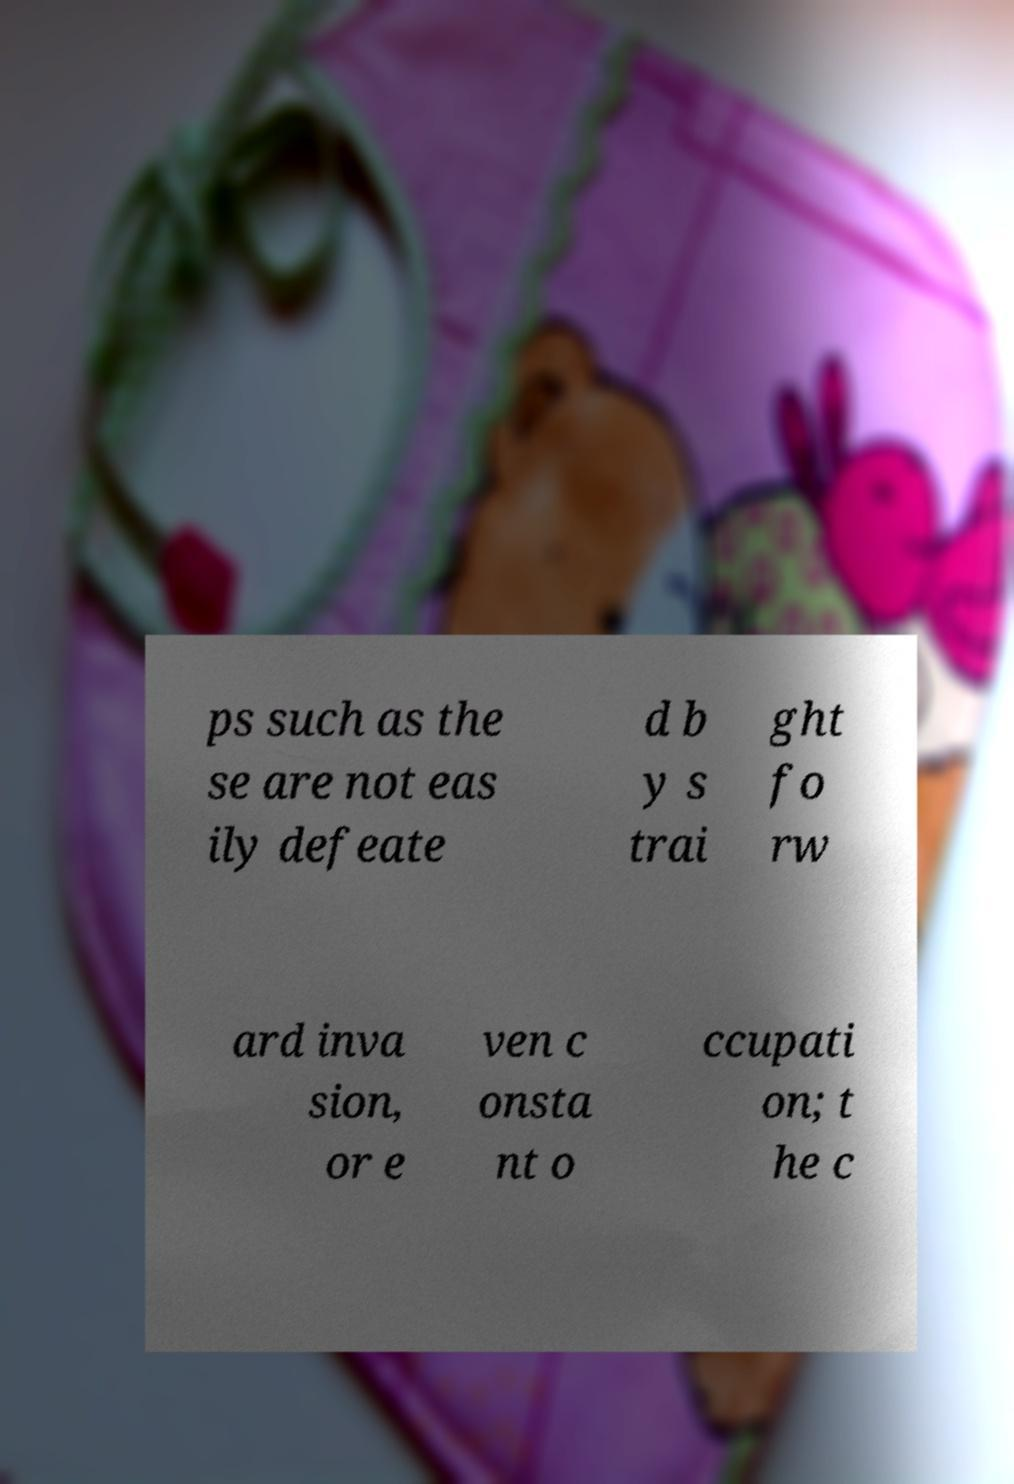Please read and relay the text visible in this image. What does it say? ps such as the se are not eas ily defeate d b y s trai ght fo rw ard inva sion, or e ven c onsta nt o ccupati on; t he c 